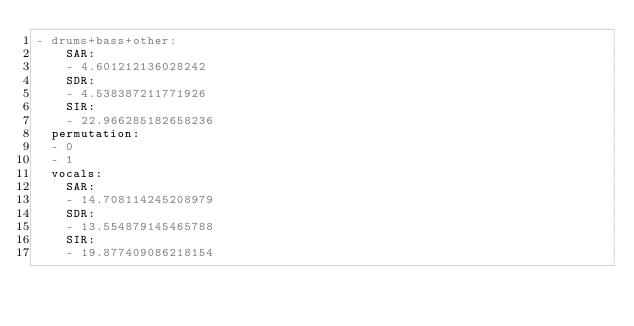<code> <loc_0><loc_0><loc_500><loc_500><_YAML_>- drums+bass+other:
    SAR:
    - 4.601212136028242
    SDR:
    - 4.538387211771926
    SIR:
    - 22.966285182658236
  permutation:
  - 0
  - 1
  vocals:
    SAR:
    - 14.708114245208979
    SDR:
    - 13.554879145465788
    SIR:
    - 19.877409086218154
</code> 